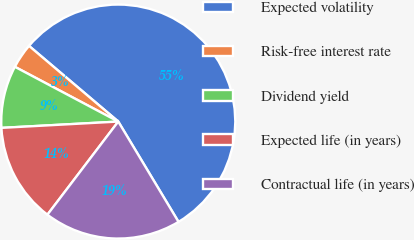Convert chart. <chart><loc_0><loc_0><loc_500><loc_500><pie_chart><fcel>Expected volatility<fcel>Risk-free interest rate<fcel>Dividend yield<fcel>Expected life (in years)<fcel>Contractual life (in years)<nl><fcel>55.2%<fcel>3.44%<fcel>8.61%<fcel>13.79%<fcel>18.96%<nl></chart> 